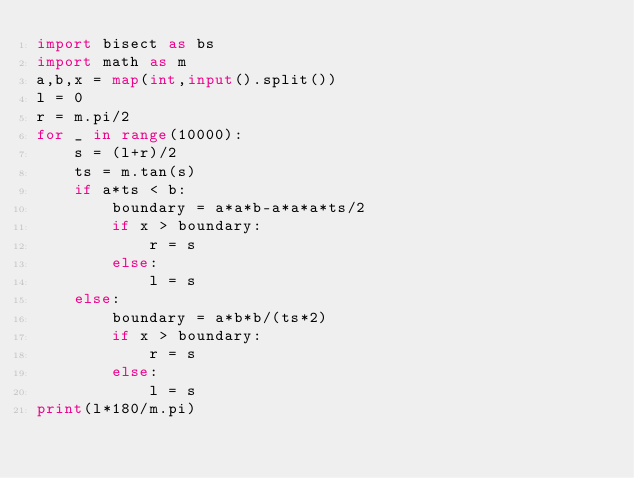Convert code to text. <code><loc_0><loc_0><loc_500><loc_500><_Python_>import bisect as bs
import math as m
a,b,x = map(int,input().split())
l = 0
r = m.pi/2
for _ in range(10000):
    s = (l+r)/2
    ts = m.tan(s)
    if a*ts < b:
        boundary = a*a*b-a*a*a*ts/2
        if x > boundary:
            r = s
        else:
            l = s
    else:
        boundary = a*b*b/(ts*2)
        if x > boundary:
            r = s
        else:
            l = s
print(l*180/m.pi)</code> 